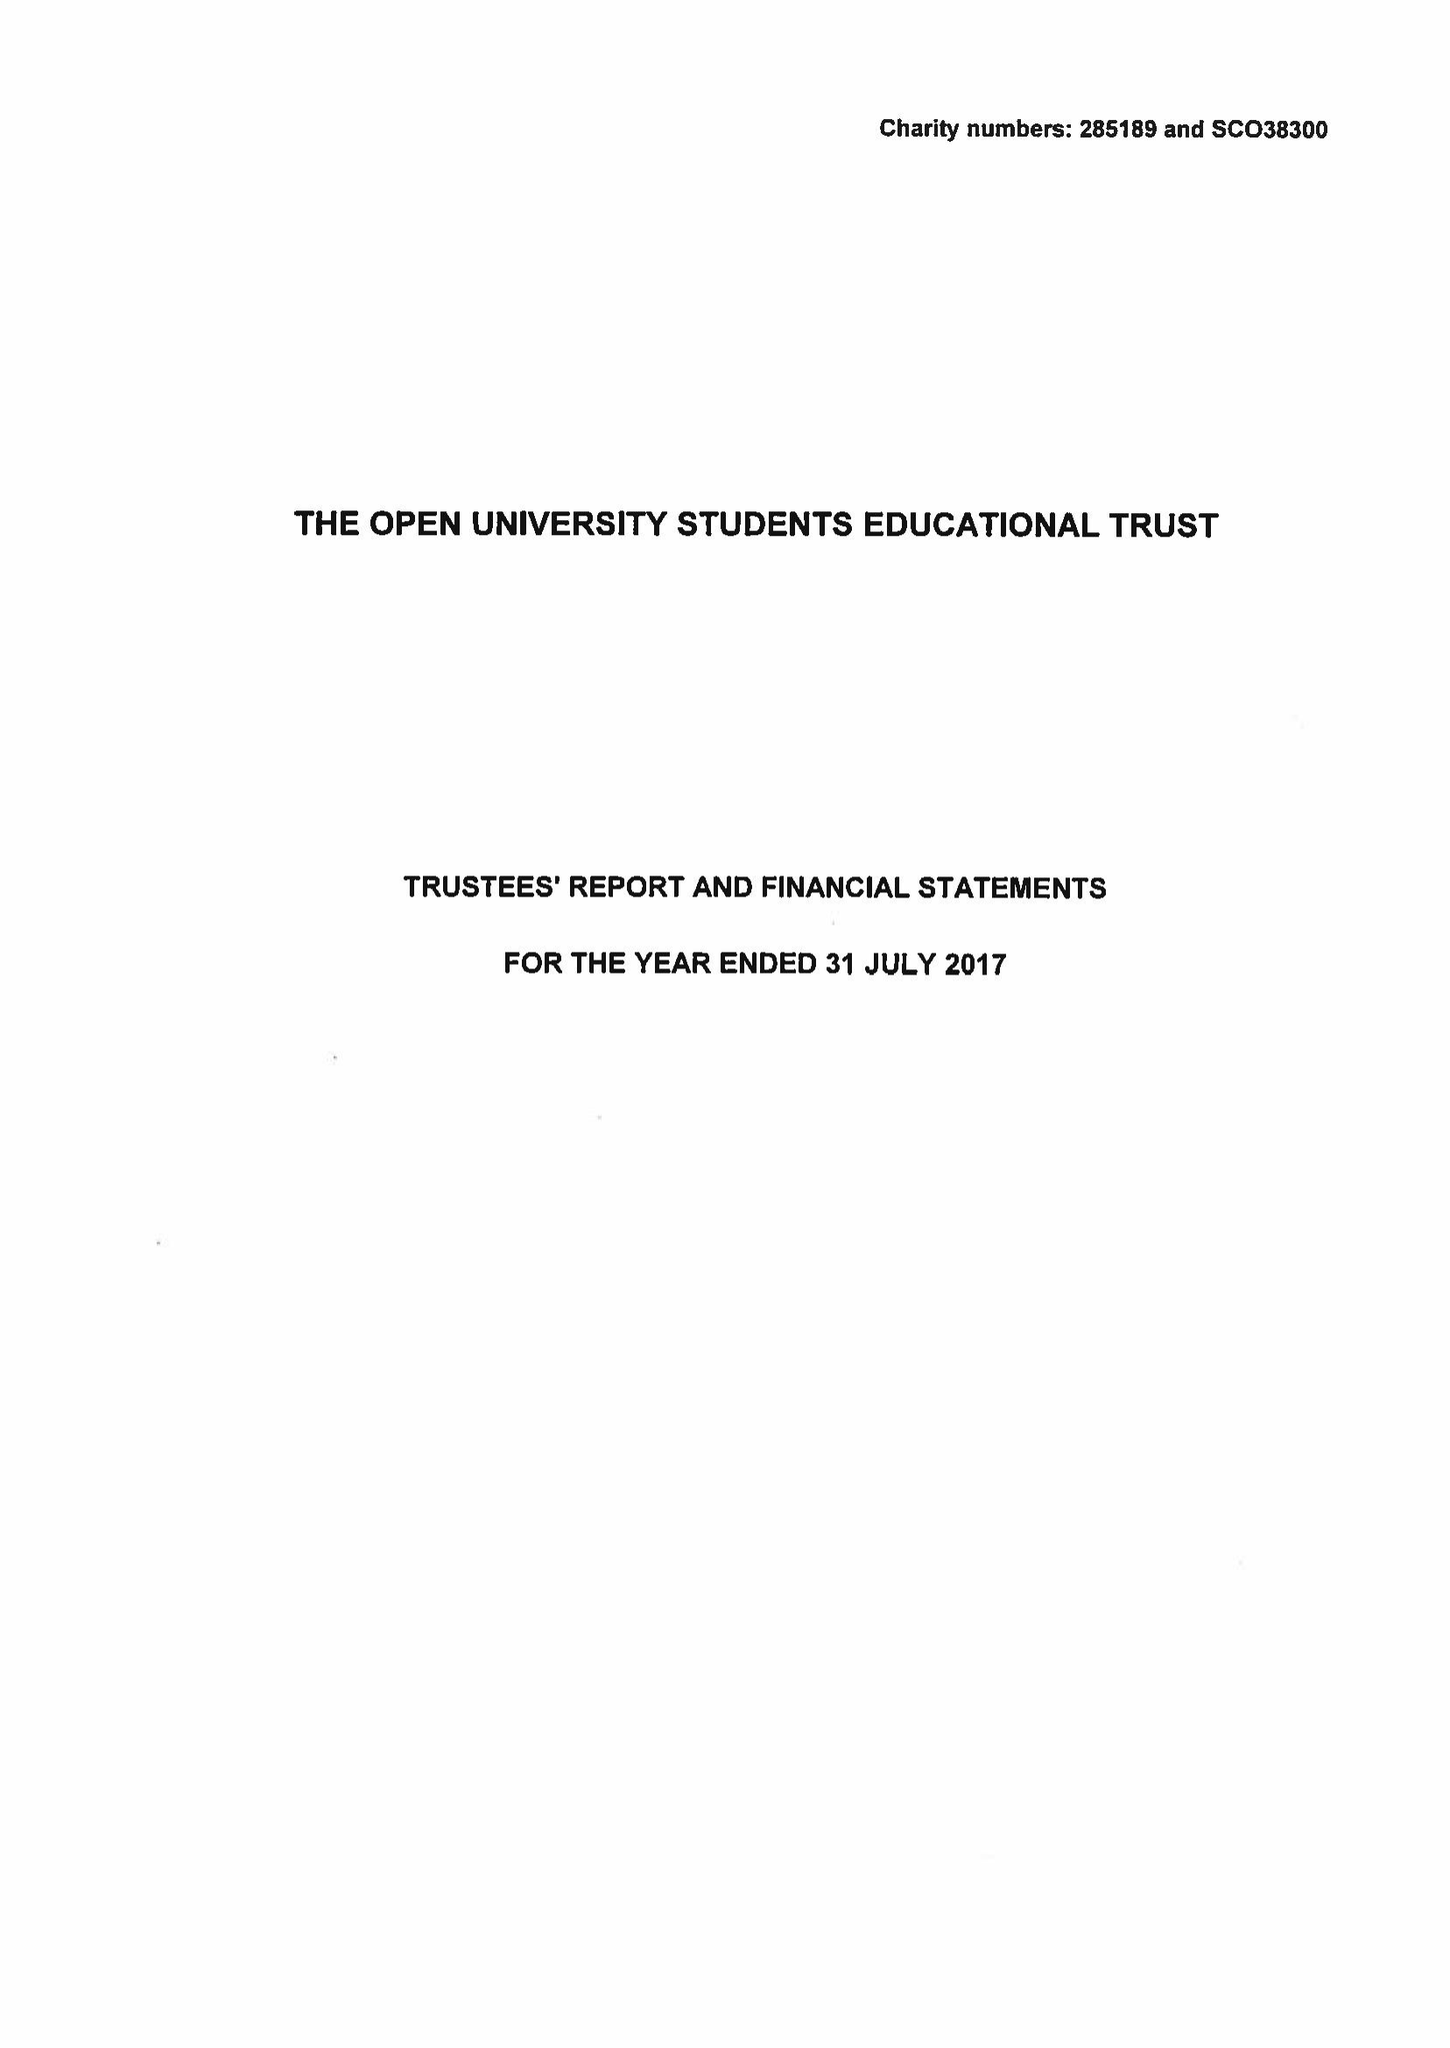What is the value for the income_annually_in_british_pounds?
Answer the question using a single word or phrase. 47238.00 